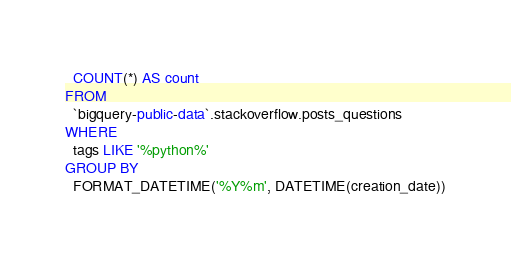<code> <loc_0><loc_0><loc_500><loc_500><_SQL_>  COUNT(*) AS count
FROM
  `bigquery-public-data`.stackoverflow.posts_questions
WHERE
  tags LIKE '%python%'
GROUP BY
  FORMAT_DATETIME('%Y%m', DATETIME(creation_date))</code> 